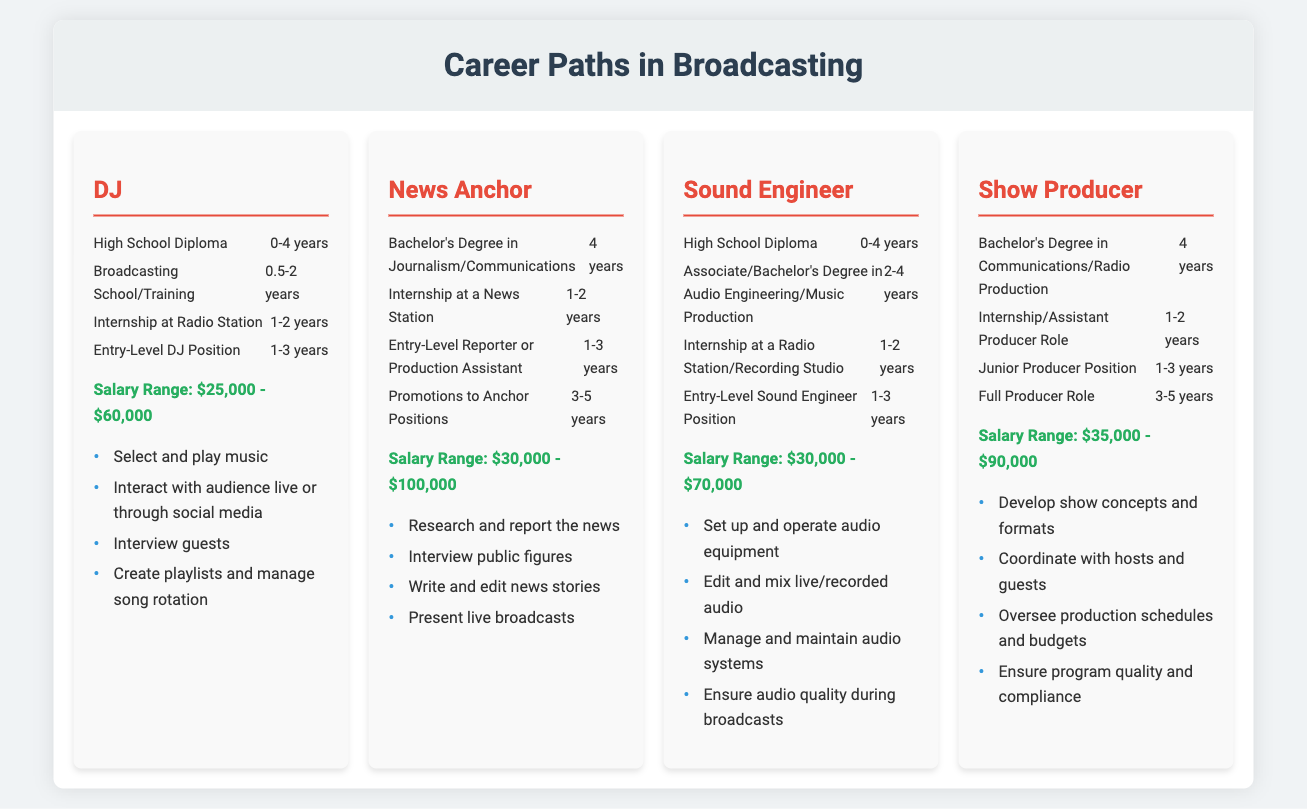What is the salary range for a DJ? The salary range for a DJ is found under the corresponding section in the document.
Answer: $25,000 - $60,000 How many years of experience are typically required for a News Anchor to get promoted to an anchor position? The number of years needed for a promotion to an anchor position is listed in the qualifications section of the News Anchor career.
Answer: 3-5 years What degree is required to become a Sound Engineer? The required degree for a Sound Engineer is mentioned in the qualifications timeline.
Answer: Associate/Bachelor's Degree in Audio Engineering/Music Production What is a primary job role of a Show Producer? A primary job role of a Show Producer can be found in the list of job roles for this career.
Answer: Develop show concepts and formats Which broadcasting career generally requires a Bachelor's degree? The careers requiring a Bachelor's degree can be compared in the educational requirement sections of each job.
Answer: News Anchor, Show Producer 